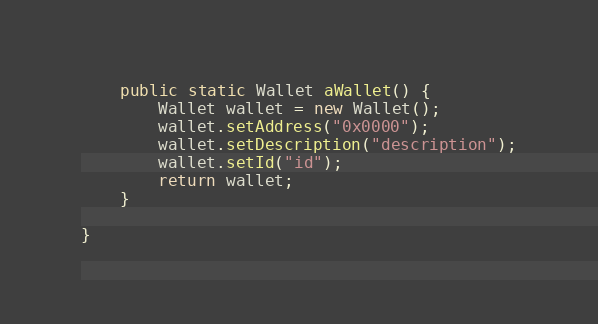<code> <loc_0><loc_0><loc_500><loc_500><_Java_>
    public static Wallet aWallet() {
        Wallet wallet = new Wallet();
        wallet.setAddress("0x0000");
        wallet.setDescription("description");
        wallet.setId("id");
        return wallet;
    }

}</code> 